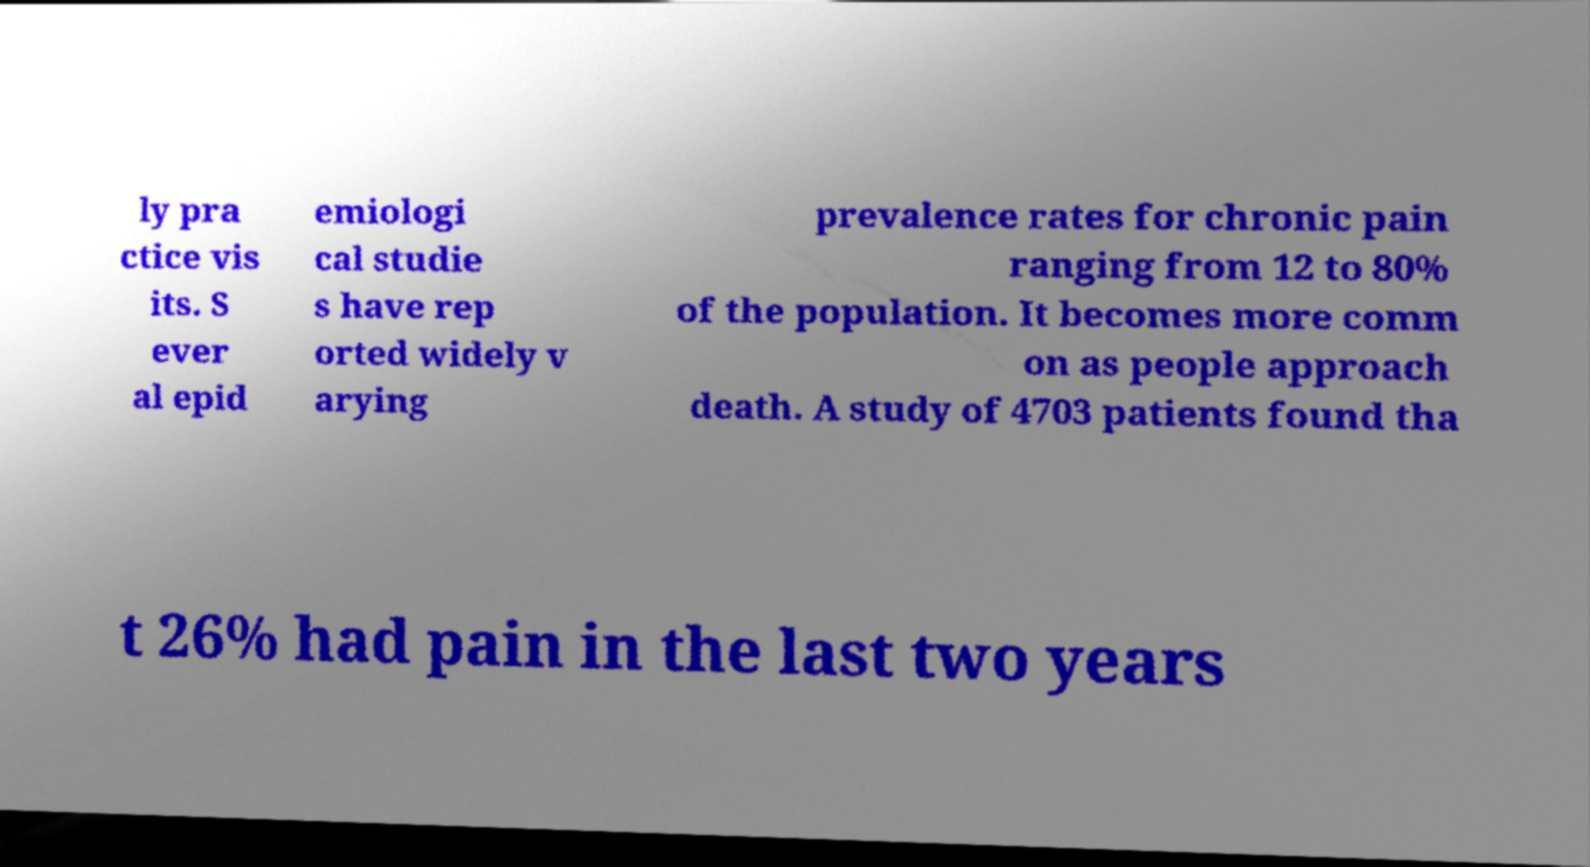Could you assist in decoding the text presented in this image and type it out clearly? ly pra ctice vis its. S ever al epid emiologi cal studie s have rep orted widely v arying prevalence rates for chronic pain ranging from 12 to 80% of the population. It becomes more comm on as people approach death. A study of 4703 patients found tha t 26% had pain in the last two years 